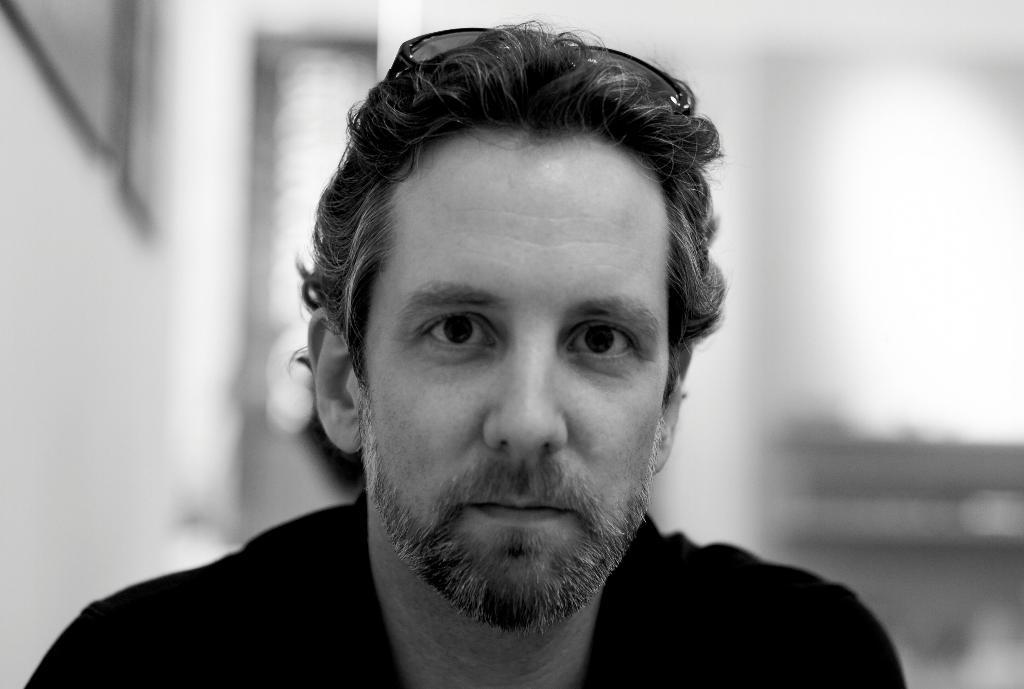What is the main subject of the image? There is a person in the image. What is the person doing in the image? The person is watching something. Can you describe the background of the image? The background of the image is blurred. What is the color scheme of the image? The image is black and white. What type of snail can be seen crawling on the person's shoulder in the image? There is no snail present in the image; the person is the main subject, and the background is blurred. 